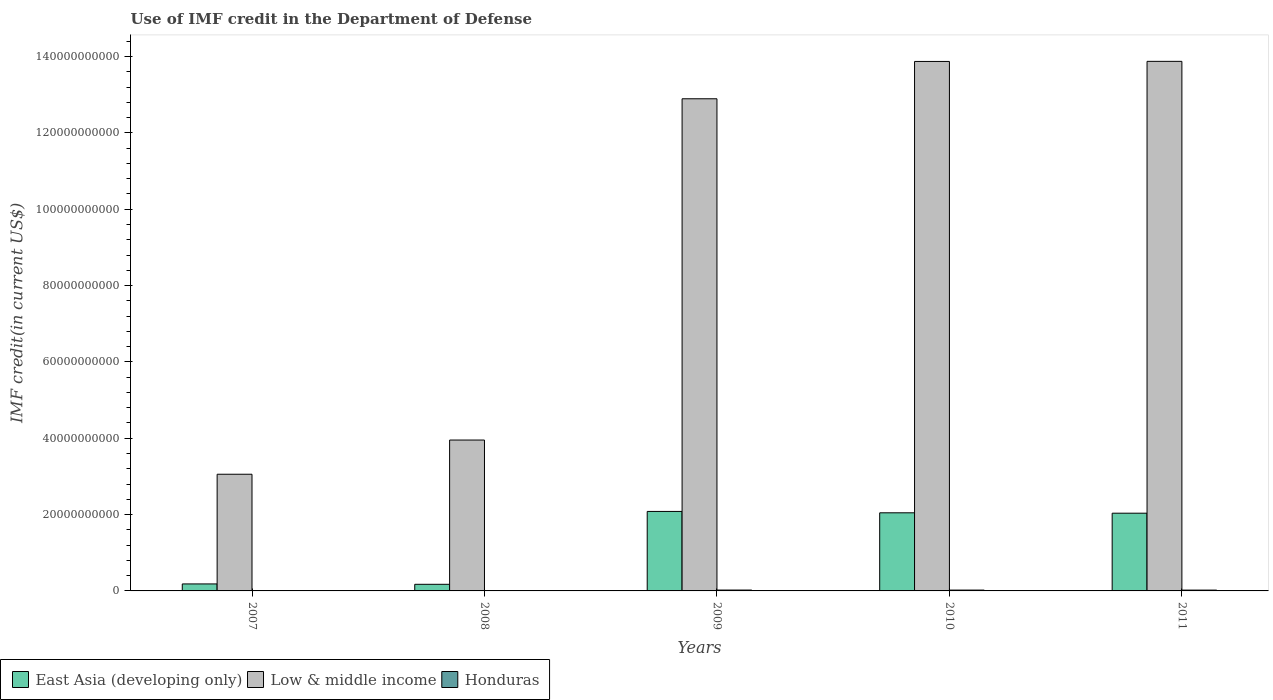Are the number of bars per tick equal to the number of legend labels?
Provide a short and direct response. Yes. Are the number of bars on each tick of the X-axis equal?
Make the answer very short. Yes. How many bars are there on the 2nd tick from the left?
Provide a succinct answer. 3. What is the label of the 4th group of bars from the left?
Provide a short and direct response. 2010. In how many cases, is the number of bars for a given year not equal to the number of legend labels?
Ensure brevity in your answer.  0. What is the IMF credit in the Department of Defense in Honduras in 2011?
Give a very brief answer. 2.15e+08. Across all years, what is the maximum IMF credit in the Department of Defense in Low & middle income?
Your answer should be compact. 1.39e+11. Across all years, what is the minimum IMF credit in the Department of Defense in Honduras?
Offer a very short reply. 6.07e+07. In which year was the IMF credit in the Department of Defense in Low & middle income minimum?
Give a very brief answer. 2007. What is the total IMF credit in the Department of Defense in East Asia (developing only) in the graph?
Keep it short and to the point. 6.52e+1. What is the difference between the IMF credit in the Department of Defense in Honduras in 2009 and that in 2010?
Provide a short and direct response. 5.56e+06. What is the difference between the IMF credit in the Department of Defense in East Asia (developing only) in 2008 and the IMF credit in the Department of Defense in Low & middle income in 2009?
Keep it short and to the point. -1.27e+11. What is the average IMF credit in the Department of Defense in Low & middle income per year?
Offer a very short reply. 9.53e+1. In the year 2009, what is the difference between the IMF credit in the Department of Defense in Honduras and IMF credit in the Department of Defense in East Asia (developing only)?
Provide a succinct answer. -2.06e+1. In how many years, is the IMF credit in the Department of Defense in East Asia (developing only) greater than 116000000000 US$?
Your answer should be compact. 0. What is the ratio of the IMF credit in the Department of Defense in Honduras in 2009 to that in 2010?
Your response must be concise. 1.03. Is the IMF credit in the Department of Defense in East Asia (developing only) in 2009 less than that in 2010?
Offer a very short reply. No. What is the difference between the highest and the second highest IMF credit in the Department of Defense in Low & middle income?
Provide a succinct answer. 2.27e+07. What is the difference between the highest and the lowest IMF credit in the Department of Defense in Honduras?
Provide a short and direct response. 1.65e+08. What does the 1st bar from the left in 2008 represents?
Keep it short and to the point. East Asia (developing only). What does the 3rd bar from the right in 2007 represents?
Ensure brevity in your answer.  East Asia (developing only). Is it the case that in every year, the sum of the IMF credit in the Department of Defense in East Asia (developing only) and IMF credit in the Department of Defense in Honduras is greater than the IMF credit in the Department of Defense in Low & middle income?
Make the answer very short. No. How many bars are there?
Keep it short and to the point. 15. Are all the bars in the graph horizontal?
Provide a short and direct response. No. How many years are there in the graph?
Provide a short and direct response. 5. Are the values on the major ticks of Y-axis written in scientific E-notation?
Your answer should be compact. No. Does the graph contain any zero values?
Offer a very short reply. No. Does the graph contain grids?
Give a very brief answer. No. How are the legend labels stacked?
Provide a short and direct response. Horizontal. What is the title of the graph?
Your response must be concise. Use of IMF credit in the Department of Defense. What is the label or title of the X-axis?
Offer a very short reply. Years. What is the label or title of the Y-axis?
Offer a very short reply. IMF credit(in current US$). What is the IMF credit(in current US$) in East Asia (developing only) in 2007?
Offer a very short reply. 1.83e+09. What is the IMF credit(in current US$) in Low & middle income in 2007?
Your answer should be compact. 3.06e+1. What is the IMF credit(in current US$) in Honduras in 2007?
Give a very brief answer. 6.23e+07. What is the IMF credit(in current US$) of East Asia (developing only) in 2008?
Keep it short and to the point. 1.73e+09. What is the IMF credit(in current US$) of Low & middle income in 2008?
Give a very brief answer. 3.95e+1. What is the IMF credit(in current US$) in Honduras in 2008?
Give a very brief answer. 6.07e+07. What is the IMF credit(in current US$) of East Asia (developing only) in 2009?
Offer a very short reply. 2.08e+1. What is the IMF credit(in current US$) in Low & middle income in 2009?
Your answer should be compact. 1.29e+11. What is the IMF credit(in current US$) in Honduras in 2009?
Offer a terse response. 2.26e+08. What is the IMF credit(in current US$) of East Asia (developing only) in 2010?
Your response must be concise. 2.05e+1. What is the IMF credit(in current US$) of Low & middle income in 2010?
Provide a succinct answer. 1.39e+11. What is the IMF credit(in current US$) of Honduras in 2010?
Provide a short and direct response. 2.20e+08. What is the IMF credit(in current US$) in East Asia (developing only) in 2011?
Your answer should be very brief. 2.04e+1. What is the IMF credit(in current US$) in Low & middle income in 2011?
Ensure brevity in your answer.  1.39e+11. What is the IMF credit(in current US$) of Honduras in 2011?
Offer a terse response. 2.15e+08. Across all years, what is the maximum IMF credit(in current US$) in East Asia (developing only)?
Your answer should be compact. 2.08e+1. Across all years, what is the maximum IMF credit(in current US$) of Low & middle income?
Provide a succinct answer. 1.39e+11. Across all years, what is the maximum IMF credit(in current US$) of Honduras?
Your answer should be very brief. 2.26e+08. Across all years, what is the minimum IMF credit(in current US$) of East Asia (developing only)?
Offer a very short reply. 1.73e+09. Across all years, what is the minimum IMF credit(in current US$) in Low & middle income?
Offer a very short reply. 3.06e+1. Across all years, what is the minimum IMF credit(in current US$) in Honduras?
Ensure brevity in your answer.  6.07e+07. What is the total IMF credit(in current US$) of East Asia (developing only) in the graph?
Your answer should be compact. 6.52e+1. What is the total IMF credit(in current US$) of Low & middle income in the graph?
Give a very brief answer. 4.76e+11. What is the total IMF credit(in current US$) of Honduras in the graph?
Keep it short and to the point. 7.85e+08. What is the difference between the IMF credit(in current US$) in East Asia (developing only) in 2007 and that in 2008?
Ensure brevity in your answer.  9.84e+07. What is the difference between the IMF credit(in current US$) of Low & middle income in 2007 and that in 2008?
Offer a very short reply. -8.96e+09. What is the difference between the IMF credit(in current US$) in Honduras in 2007 and that in 2008?
Make the answer very short. 1.58e+06. What is the difference between the IMF credit(in current US$) in East Asia (developing only) in 2007 and that in 2009?
Give a very brief answer. -1.90e+1. What is the difference between the IMF credit(in current US$) of Low & middle income in 2007 and that in 2009?
Keep it short and to the point. -9.84e+1. What is the difference between the IMF credit(in current US$) of Honduras in 2007 and that in 2009?
Keep it short and to the point. -1.64e+08. What is the difference between the IMF credit(in current US$) of East Asia (developing only) in 2007 and that in 2010?
Your answer should be compact. -1.86e+1. What is the difference between the IMF credit(in current US$) of Low & middle income in 2007 and that in 2010?
Your response must be concise. -1.08e+11. What is the difference between the IMF credit(in current US$) of Honduras in 2007 and that in 2010?
Give a very brief answer. -1.58e+08. What is the difference between the IMF credit(in current US$) in East Asia (developing only) in 2007 and that in 2011?
Ensure brevity in your answer.  -1.85e+1. What is the difference between the IMF credit(in current US$) in Low & middle income in 2007 and that in 2011?
Ensure brevity in your answer.  -1.08e+11. What is the difference between the IMF credit(in current US$) of Honduras in 2007 and that in 2011?
Ensure brevity in your answer.  -1.53e+08. What is the difference between the IMF credit(in current US$) in East Asia (developing only) in 2008 and that in 2009?
Provide a succinct answer. -1.91e+1. What is the difference between the IMF credit(in current US$) in Low & middle income in 2008 and that in 2009?
Your response must be concise. -8.94e+1. What is the difference between the IMF credit(in current US$) in Honduras in 2008 and that in 2009?
Give a very brief answer. -1.65e+08. What is the difference between the IMF credit(in current US$) of East Asia (developing only) in 2008 and that in 2010?
Offer a very short reply. -1.87e+1. What is the difference between the IMF credit(in current US$) of Low & middle income in 2008 and that in 2010?
Your answer should be compact. -9.92e+1. What is the difference between the IMF credit(in current US$) of Honduras in 2008 and that in 2010?
Make the answer very short. -1.60e+08. What is the difference between the IMF credit(in current US$) of East Asia (developing only) in 2008 and that in 2011?
Your answer should be very brief. -1.86e+1. What is the difference between the IMF credit(in current US$) of Low & middle income in 2008 and that in 2011?
Give a very brief answer. -9.92e+1. What is the difference between the IMF credit(in current US$) of Honduras in 2008 and that in 2011?
Ensure brevity in your answer.  -1.54e+08. What is the difference between the IMF credit(in current US$) in East Asia (developing only) in 2009 and that in 2010?
Give a very brief answer. 3.60e+08. What is the difference between the IMF credit(in current US$) of Low & middle income in 2009 and that in 2010?
Ensure brevity in your answer.  -9.78e+09. What is the difference between the IMF credit(in current US$) of Honduras in 2009 and that in 2010?
Keep it short and to the point. 5.56e+06. What is the difference between the IMF credit(in current US$) in East Asia (developing only) in 2009 and that in 2011?
Your response must be concise. 4.61e+08. What is the difference between the IMF credit(in current US$) of Low & middle income in 2009 and that in 2011?
Your response must be concise. -9.80e+09. What is the difference between the IMF credit(in current US$) in Honduras in 2009 and that in 2011?
Provide a short and direct response. 1.09e+07. What is the difference between the IMF credit(in current US$) of East Asia (developing only) in 2010 and that in 2011?
Your answer should be very brief. 1.02e+08. What is the difference between the IMF credit(in current US$) of Low & middle income in 2010 and that in 2011?
Give a very brief answer. -2.27e+07. What is the difference between the IMF credit(in current US$) in Honduras in 2010 and that in 2011?
Offer a terse response. 5.36e+06. What is the difference between the IMF credit(in current US$) of East Asia (developing only) in 2007 and the IMF credit(in current US$) of Low & middle income in 2008?
Your response must be concise. -3.77e+1. What is the difference between the IMF credit(in current US$) in East Asia (developing only) in 2007 and the IMF credit(in current US$) in Honduras in 2008?
Your response must be concise. 1.77e+09. What is the difference between the IMF credit(in current US$) of Low & middle income in 2007 and the IMF credit(in current US$) of Honduras in 2008?
Give a very brief answer. 3.05e+1. What is the difference between the IMF credit(in current US$) of East Asia (developing only) in 2007 and the IMF credit(in current US$) of Low & middle income in 2009?
Keep it short and to the point. -1.27e+11. What is the difference between the IMF credit(in current US$) in East Asia (developing only) in 2007 and the IMF credit(in current US$) in Honduras in 2009?
Make the answer very short. 1.61e+09. What is the difference between the IMF credit(in current US$) in Low & middle income in 2007 and the IMF credit(in current US$) in Honduras in 2009?
Ensure brevity in your answer.  3.03e+1. What is the difference between the IMF credit(in current US$) of East Asia (developing only) in 2007 and the IMF credit(in current US$) of Low & middle income in 2010?
Give a very brief answer. -1.37e+11. What is the difference between the IMF credit(in current US$) in East Asia (developing only) in 2007 and the IMF credit(in current US$) in Honduras in 2010?
Give a very brief answer. 1.61e+09. What is the difference between the IMF credit(in current US$) in Low & middle income in 2007 and the IMF credit(in current US$) in Honduras in 2010?
Your response must be concise. 3.03e+1. What is the difference between the IMF credit(in current US$) in East Asia (developing only) in 2007 and the IMF credit(in current US$) in Low & middle income in 2011?
Your response must be concise. -1.37e+11. What is the difference between the IMF credit(in current US$) of East Asia (developing only) in 2007 and the IMF credit(in current US$) of Honduras in 2011?
Offer a very short reply. 1.62e+09. What is the difference between the IMF credit(in current US$) of Low & middle income in 2007 and the IMF credit(in current US$) of Honduras in 2011?
Your response must be concise. 3.04e+1. What is the difference between the IMF credit(in current US$) of East Asia (developing only) in 2008 and the IMF credit(in current US$) of Low & middle income in 2009?
Keep it short and to the point. -1.27e+11. What is the difference between the IMF credit(in current US$) of East Asia (developing only) in 2008 and the IMF credit(in current US$) of Honduras in 2009?
Your response must be concise. 1.51e+09. What is the difference between the IMF credit(in current US$) in Low & middle income in 2008 and the IMF credit(in current US$) in Honduras in 2009?
Your answer should be very brief. 3.93e+1. What is the difference between the IMF credit(in current US$) in East Asia (developing only) in 2008 and the IMF credit(in current US$) in Low & middle income in 2010?
Ensure brevity in your answer.  -1.37e+11. What is the difference between the IMF credit(in current US$) in East Asia (developing only) in 2008 and the IMF credit(in current US$) in Honduras in 2010?
Provide a succinct answer. 1.51e+09. What is the difference between the IMF credit(in current US$) of Low & middle income in 2008 and the IMF credit(in current US$) of Honduras in 2010?
Provide a short and direct response. 3.93e+1. What is the difference between the IMF credit(in current US$) in East Asia (developing only) in 2008 and the IMF credit(in current US$) in Low & middle income in 2011?
Your answer should be very brief. -1.37e+11. What is the difference between the IMF credit(in current US$) of East Asia (developing only) in 2008 and the IMF credit(in current US$) of Honduras in 2011?
Make the answer very short. 1.52e+09. What is the difference between the IMF credit(in current US$) in Low & middle income in 2008 and the IMF credit(in current US$) in Honduras in 2011?
Your answer should be compact. 3.93e+1. What is the difference between the IMF credit(in current US$) in East Asia (developing only) in 2009 and the IMF credit(in current US$) in Low & middle income in 2010?
Keep it short and to the point. -1.18e+11. What is the difference between the IMF credit(in current US$) of East Asia (developing only) in 2009 and the IMF credit(in current US$) of Honduras in 2010?
Keep it short and to the point. 2.06e+1. What is the difference between the IMF credit(in current US$) of Low & middle income in 2009 and the IMF credit(in current US$) of Honduras in 2010?
Provide a short and direct response. 1.29e+11. What is the difference between the IMF credit(in current US$) of East Asia (developing only) in 2009 and the IMF credit(in current US$) of Low & middle income in 2011?
Your answer should be very brief. -1.18e+11. What is the difference between the IMF credit(in current US$) of East Asia (developing only) in 2009 and the IMF credit(in current US$) of Honduras in 2011?
Provide a succinct answer. 2.06e+1. What is the difference between the IMF credit(in current US$) in Low & middle income in 2009 and the IMF credit(in current US$) in Honduras in 2011?
Offer a terse response. 1.29e+11. What is the difference between the IMF credit(in current US$) of East Asia (developing only) in 2010 and the IMF credit(in current US$) of Low & middle income in 2011?
Offer a terse response. -1.18e+11. What is the difference between the IMF credit(in current US$) in East Asia (developing only) in 2010 and the IMF credit(in current US$) in Honduras in 2011?
Offer a terse response. 2.02e+1. What is the difference between the IMF credit(in current US$) of Low & middle income in 2010 and the IMF credit(in current US$) of Honduras in 2011?
Your response must be concise. 1.38e+11. What is the average IMF credit(in current US$) of East Asia (developing only) per year?
Keep it short and to the point. 1.30e+1. What is the average IMF credit(in current US$) in Low & middle income per year?
Your answer should be compact. 9.53e+1. What is the average IMF credit(in current US$) in Honduras per year?
Offer a very short reply. 1.57e+08. In the year 2007, what is the difference between the IMF credit(in current US$) of East Asia (developing only) and IMF credit(in current US$) of Low & middle income?
Keep it short and to the point. -2.87e+1. In the year 2007, what is the difference between the IMF credit(in current US$) in East Asia (developing only) and IMF credit(in current US$) in Honduras?
Offer a very short reply. 1.77e+09. In the year 2007, what is the difference between the IMF credit(in current US$) of Low & middle income and IMF credit(in current US$) of Honduras?
Give a very brief answer. 3.05e+1. In the year 2008, what is the difference between the IMF credit(in current US$) in East Asia (developing only) and IMF credit(in current US$) in Low & middle income?
Make the answer very short. -3.78e+1. In the year 2008, what is the difference between the IMF credit(in current US$) in East Asia (developing only) and IMF credit(in current US$) in Honduras?
Your response must be concise. 1.67e+09. In the year 2008, what is the difference between the IMF credit(in current US$) of Low & middle income and IMF credit(in current US$) of Honduras?
Offer a very short reply. 3.95e+1. In the year 2009, what is the difference between the IMF credit(in current US$) in East Asia (developing only) and IMF credit(in current US$) in Low & middle income?
Provide a succinct answer. -1.08e+11. In the year 2009, what is the difference between the IMF credit(in current US$) in East Asia (developing only) and IMF credit(in current US$) in Honduras?
Make the answer very short. 2.06e+1. In the year 2009, what is the difference between the IMF credit(in current US$) in Low & middle income and IMF credit(in current US$) in Honduras?
Offer a terse response. 1.29e+11. In the year 2010, what is the difference between the IMF credit(in current US$) in East Asia (developing only) and IMF credit(in current US$) in Low & middle income?
Keep it short and to the point. -1.18e+11. In the year 2010, what is the difference between the IMF credit(in current US$) in East Asia (developing only) and IMF credit(in current US$) in Honduras?
Offer a terse response. 2.02e+1. In the year 2010, what is the difference between the IMF credit(in current US$) of Low & middle income and IMF credit(in current US$) of Honduras?
Provide a short and direct response. 1.38e+11. In the year 2011, what is the difference between the IMF credit(in current US$) in East Asia (developing only) and IMF credit(in current US$) in Low & middle income?
Your answer should be very brief. -1.18e+11. In the year 2011, what is the difference between the IMF credit(in current US$) of East Asia (developing only) and IMF credit(in current US$) of Honduras?
Your answer should be compact. 2.01e+1. In the year 2011, what is the difference between the IMF credit(in current US$) of Low & middle income and IMF credit(in current US$) of Honduras?
Keep it short and to the point. 1.39e+11. What is the ratio of the IMF credit(in current US$) in East Asia (developing only) in 2007 to that in 2008?
Provide a succinct answer. 1.06. What is the ratio of the IMF credit(in current US$) in Low & middle income in 2007 to that in 2008?
Provide a short and direct response. 0.77. What is the ratio of the IMF credit(in current US$) of East Asia (developing only) in 2007 to that in 2009?
Your response must be concise. 0.09. What is the ratio of the IMF credit(in current US$) of Low & middle income in 2007 to that in 2009?
Your response must be concise. 0.24. What is the ratio of the IMF credit(in current US$) of Honduras in 2007 to that in 2009?
Offer a very short reply. 0.28. What is the ratio of the IMF credit(in current US$) in East Asia (developing only) in 2007 to that in 2010?
Ensure brevity in your answer.  0.09. What is the ratio of the IMF credit(in current US$) in Low & middle income in 2007 to that in 2010?
Make the answer very short. 0.22. What is the ratio of the IMF credit(in current US$) of Honduras in 2007 to that in 2010?
Give a very brief answer. 0.28. What is the ratio of the IMF credit(in current US$) in East Asia (developing only) in 2007 to that in 2011?
Make the answer very short. 0.09. What is the ratio of the IMF credit(in current US$) of Low & middle income in 2007 to that in 2011?
Give a very brief answer. 0.22. What is the ratio of the IMF credit(in current US$) in Honduras in 2007 to that in 2011?
Your answer should be compact. 0.29. What is the ratio of the IMF credit(in current US$) of East Asia (developing only) in 2008 to that in 2009?
Make the answer very short. 0.08. What is the ratio of the IMF credit(in current US$) of Low & middle income in 2008 to that in 2009?
Your answer should be compact. 0.31. What is the ratio of the IMF credit(in current US$) of Honduras in 2008 to that in 2009?
Provide a short and direct response. 0.27. What is the ratio of the IMF credit(in current US$) in East Asia (developing only) in 2008 to that in 2010?
Offer a very short reply. 0.08. What is the ratio of the IMF credit(in current US$) of Low & middle income in 2008 to that in 2010?
Provide a short and direct response. 0.28. What is the ratio of the IMF credit(in current US$) of Honduras in 2008 to that in 2010?
Your answer should be compact. 0.28. What is the ratio of the IMF credit(in current US$) of East Asia (developing only) in 2008 to that in 2011?
Offer a terse response. 0.09. What is the ratio of the IMF credit(in current US$) of Low & middle income in 2008 to that in 2011?
Offer a very short reply. 0.28. What is the ratio of the IMF credit(in current US$) of Honduras in 2008 to that in 2011?
Offer a very short reply. 0.28. What is the ratio of the IMF credit(in current US$) in East Asia (developing only) in 2009 to that in 2010?
Provide a succinct answer. 1.02. What is the ratio of the IMF credit(in current US$) of Low & middle income in 2009 to that in 2010?
Your answer should be very brief. 0.93. What is the ratio of the IMF credit(in current US$) of Honduras in 2009 to that in 2010?
Your answer should be very brief. 1.03. What is the ratio of the IMF credit(in current US$) of East Asia (developing only) in 2009 to that in 2011?
Give a very brief answer. 1.02. What is the ratio of the IMF credit(in current US$) in Low & middle income in 2009 to that in 2011?
Provide a short and direct response. 0.93. What is the ratio of the IMF credit(in current US$) in Honduras in 2009 to that in 2011?
Your response must be concise. 1.05. What is the ratio of the IMF credit(in current US$) in East Asia (developing only) in 2010 to that in 2011?
Give a very brief answer. 1. What is the ratio of the IMF credit(in current US$) of Low & middle income in 2010 to that in 2011?
Offer a very short reply. 1. What is the ratio of the IMF credit(in current US$) in Honduras in 2010 to that in 2011?
Your response must be concise. 1.02. What is the difference between the highest and the second highest IMF credit(in current US$) of East Asia (developing only)?
Offer a terse response. 3.60e+08. What is the difference between the highest and the second highest IMF credit(in current US$) of Low & middle income?
Your answer should be very brief. 2.27e+07. What is the difference between the highest and the second highest IMF credit(in current US$) of Honduras?
Your answer should be compact. 5.56e+06. What is the difference between the highest and the lowest IMF credit(in current US$) in East Asia (developing only)?
Your answer should be compact. 1.91e+1. What is the difference between the highest and the lowest IMF credit(in current US$) in Low & middle income?
Your answer should be compact. 1.08e+11. What is the difference between the highest and the lowest IMF credit(in current US$) of Honduras?
Provide a succinct answer. 1.65e+08. 